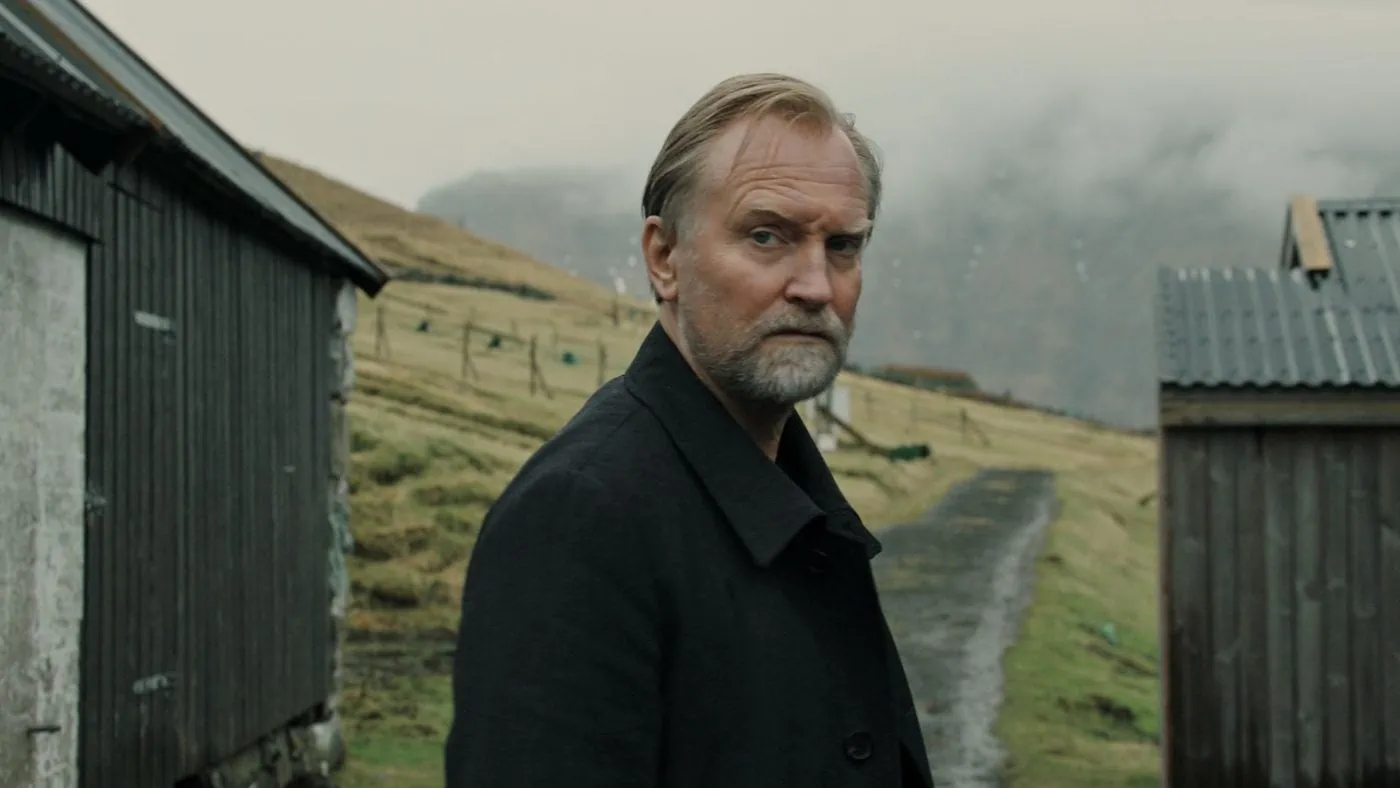What could the wooden shed symbolize in this image? In this image, the wooden shed could symbolize multiple things. It might represent a sense of nostalgia, a nod to simpler times and the durability of the past. The shed’s weathered exterior suggests resilience and history, implying that it has stood the test of time despite the elements. Alternatively, it could symbolize the undiscovered or repressed memories of the man, standing as a silent keeper of secrets and stories untold. The juxtaposition of the man’s contemplative expression against the backdrop of the humble shed adds layers to the visual narrative, deepening the viewer’s connection to the portrayed scene. 